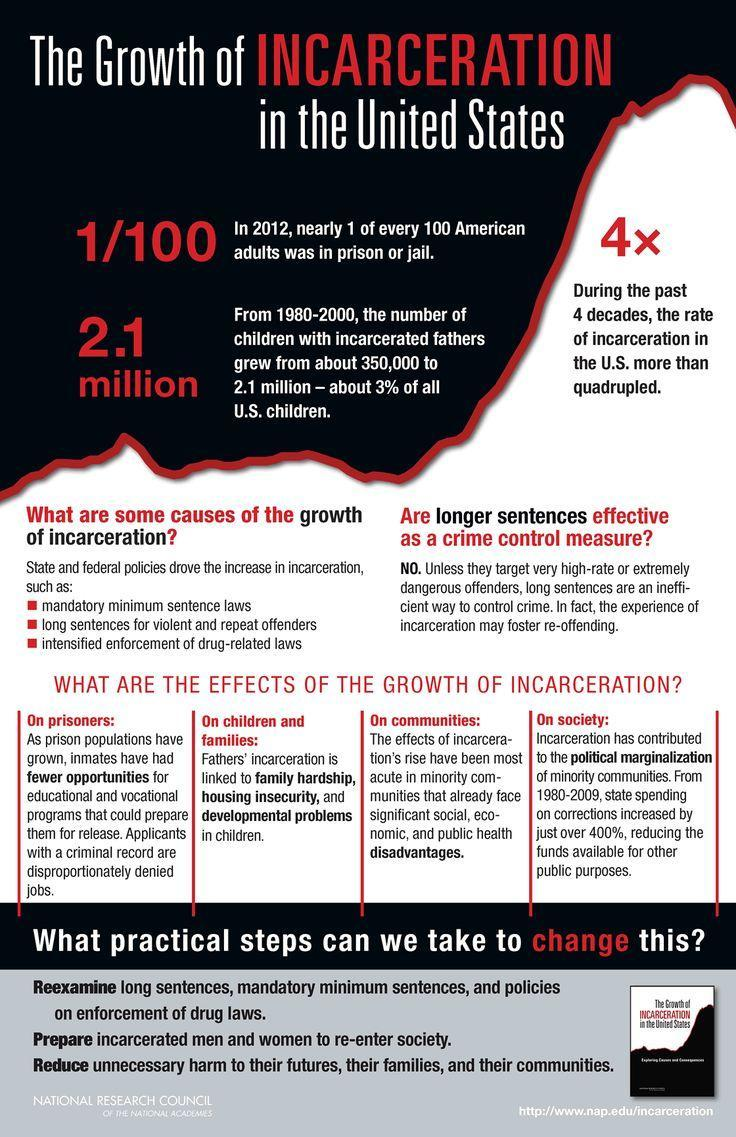What is the no of children with incarcerated fathers from 1980-2000 in U.S.?
Answer the question with a short phrase. 2.1 million 